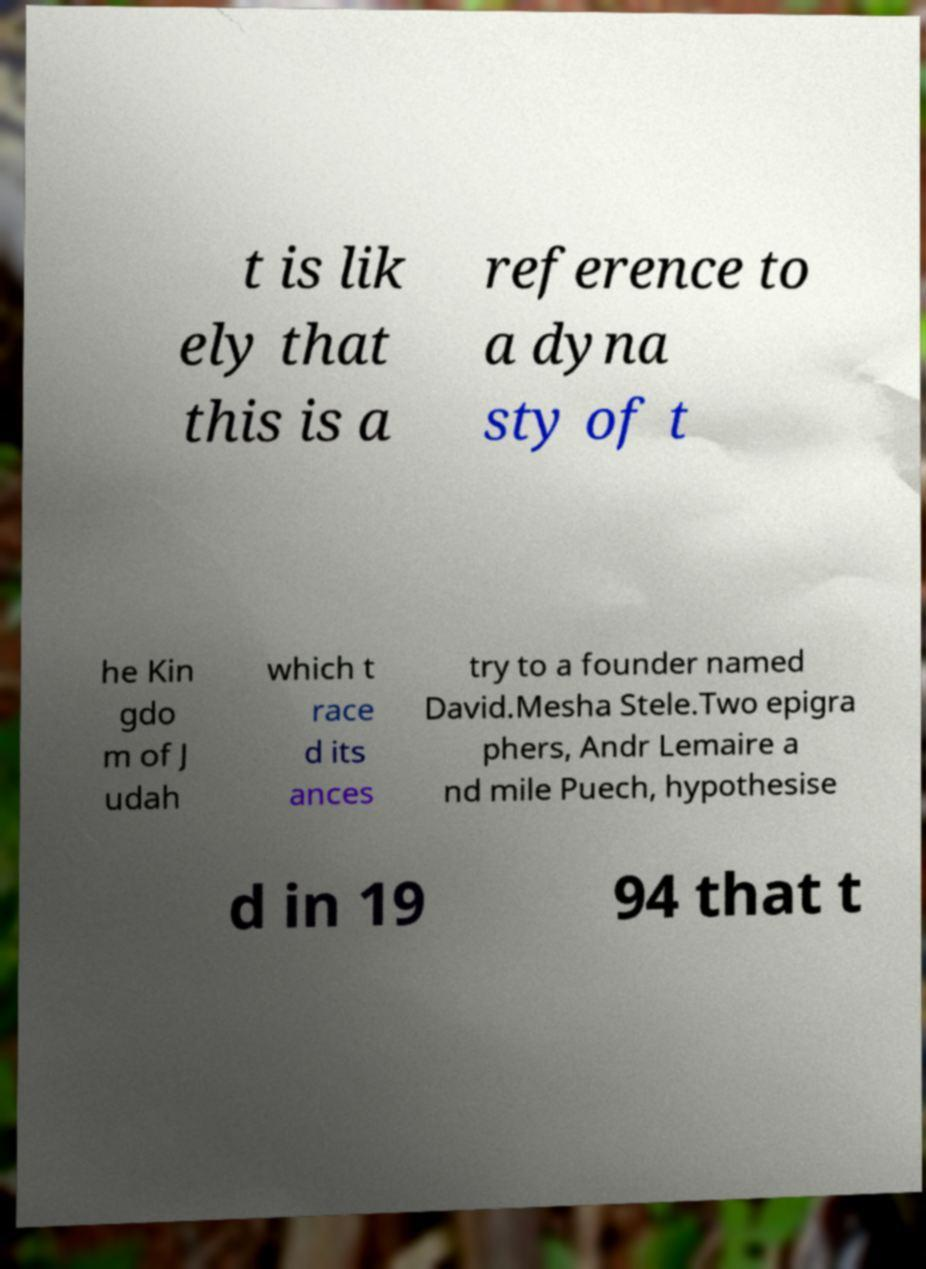Could you extract and type out the text from this image? t is lik ely that this is a reference to a dyna sty of t he Kin gdo m of J udah which t race d its ances try to a founder named David.Mesha Stele.Two epigra phers, Andr Lemaire a nd mile Puech, hypothesise d in 19 94 that t 